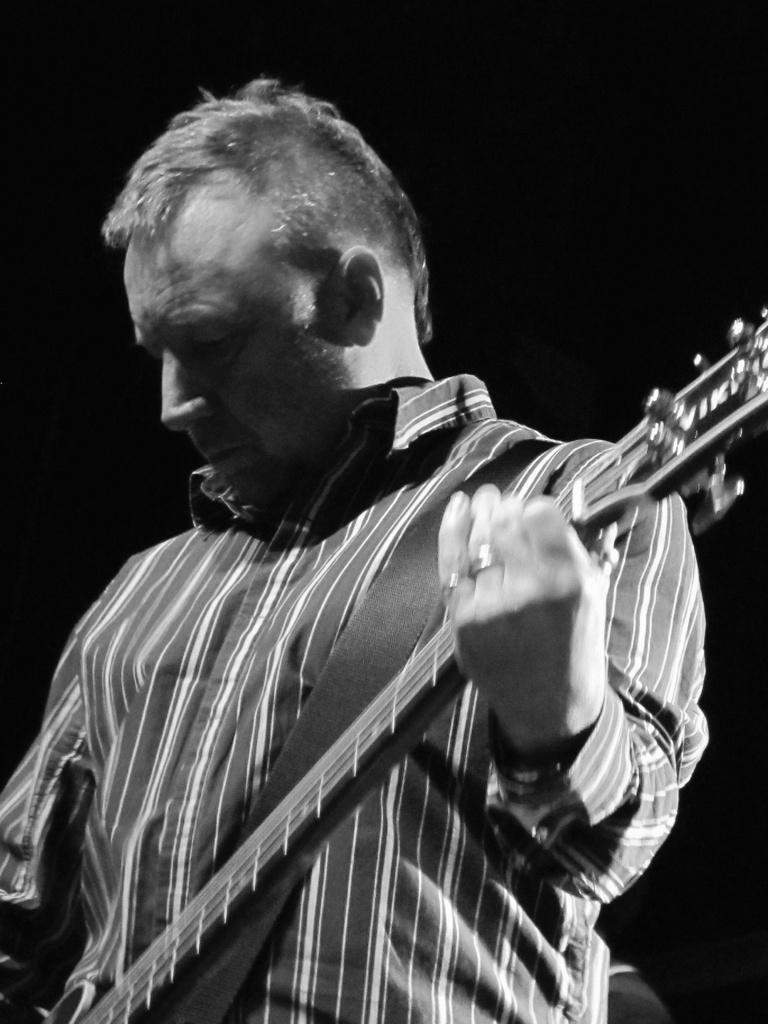In one or two sentences, can you explain what this image depicts? He is standing. He is holding a guitar. His a playing a guitar. He's wearing a colorful black check shirt. 